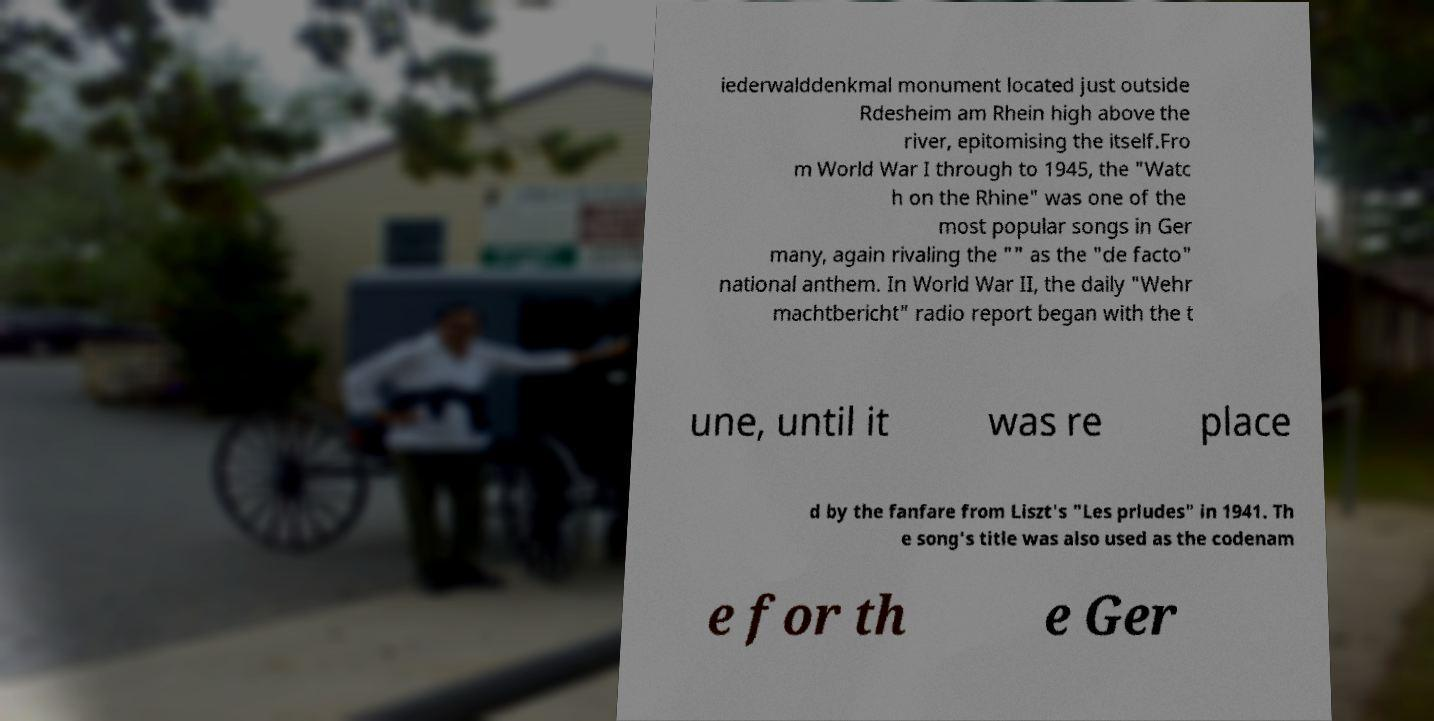Could you extract and type out the text from this image? iederwalddenkmal monument located just outside Rdesheim am Rhein high above the river, epitomising the itself.Fro m World War I through to 1945, the "Watc h on the Rhine" was one of the most popular songs in Ger many, again rivaling the "" as the "de facto" national anthem. In World War II, the daily "Wehr machtbericht" radio report began with the t une, until it was re place d by the fanfare from Liszt's "Les prludes" in 1941. Th e song's title was also used as the codenam e for th e Ger 